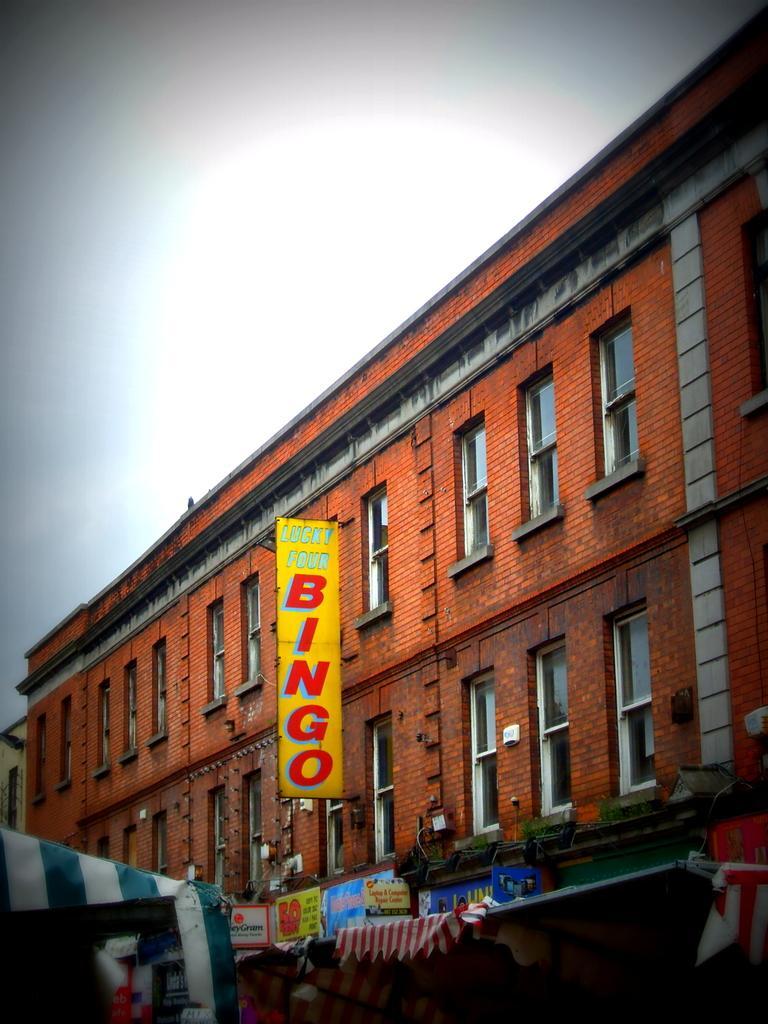Describe this image in one or two sentences. In this image we can see a building with boards and text written on the boards and there is a tent, lights and windows to the building and sky on the top. 